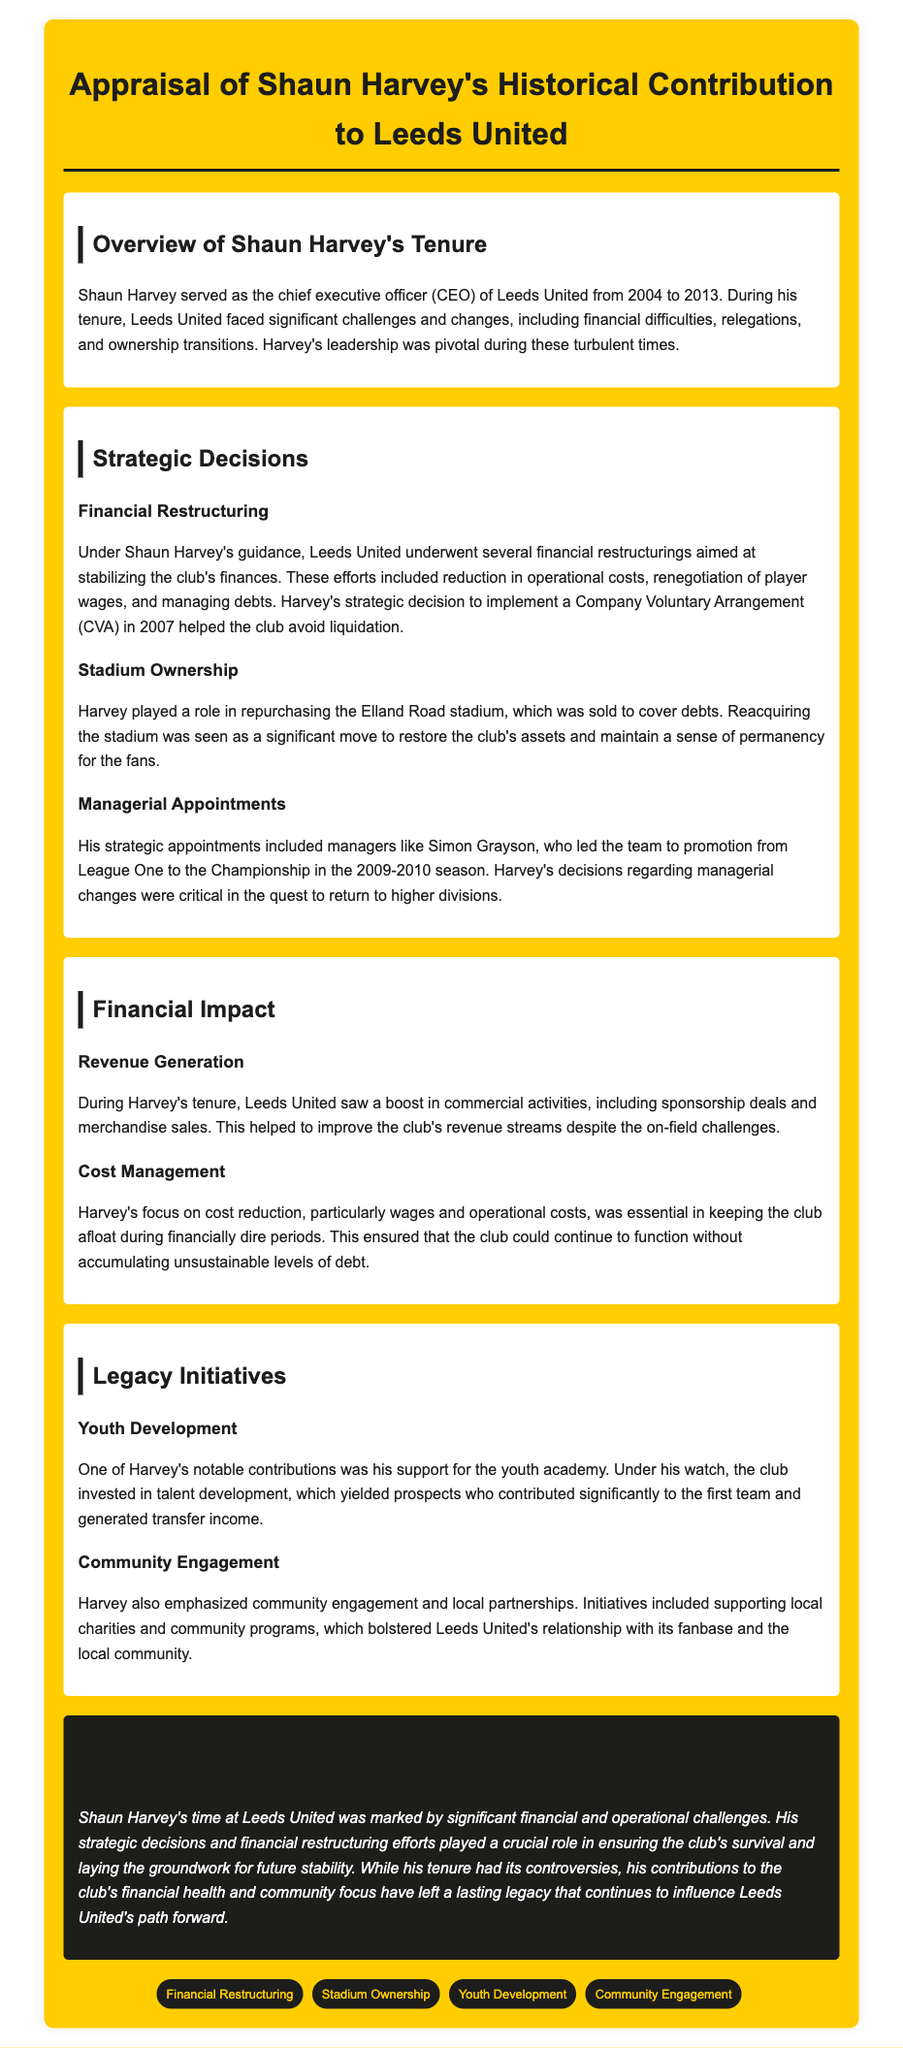What years did Shaun Harvey serve as CEO of Leeds United? The document states that Shaun Harvey served as CEO from 2004 to 2013.
Answer: 2004 to 2013 What financial restructuring action did Shaun Harvey implement in 2007? The document mentions that Shaun Harvey's strategic decision to implement a Company Voluntary Arrangement (CVA) in 2007 helped avoid liquidation.
Answer: Company Voluntary Arrangement (CVA) Who was a notable managerial appointment made by Shaun Harvey? The document highlights Simon Grayson as a significant managerial appointment who led the team to promotion.
Answer: Simon Grayson What significant asset did Harvey help to repurchase? The document states that Harvey played a role in repurchasing the Elland Road stadium.
Answer: Elland Road stadium What was one of the key focuses of Harvey's legacy initiatives? The document specifies that one of Harvey's notable contributions was support for the youth academy.
Answer: Youth academy How did Harvey impact Leeds United's revenue generation? The document mentions that there was a boost in commercial activities during Harvey's tenure, improving revenue streams.
Answer: Boost in commercial activities Which community initiative was emphasized during Shaun Harvey's tenure? The document indicates that Harvey emphasized community engagement and local partnerships, including supporting local charities.
Answer: Supporting local charities What was a critical outcome of Harvey's focus on cost management? According to the document, Harvey's focus on cost reduction ensured the club could function without accumulating unsustainable levels of debt.
Answer: Function without unsustainable debt 